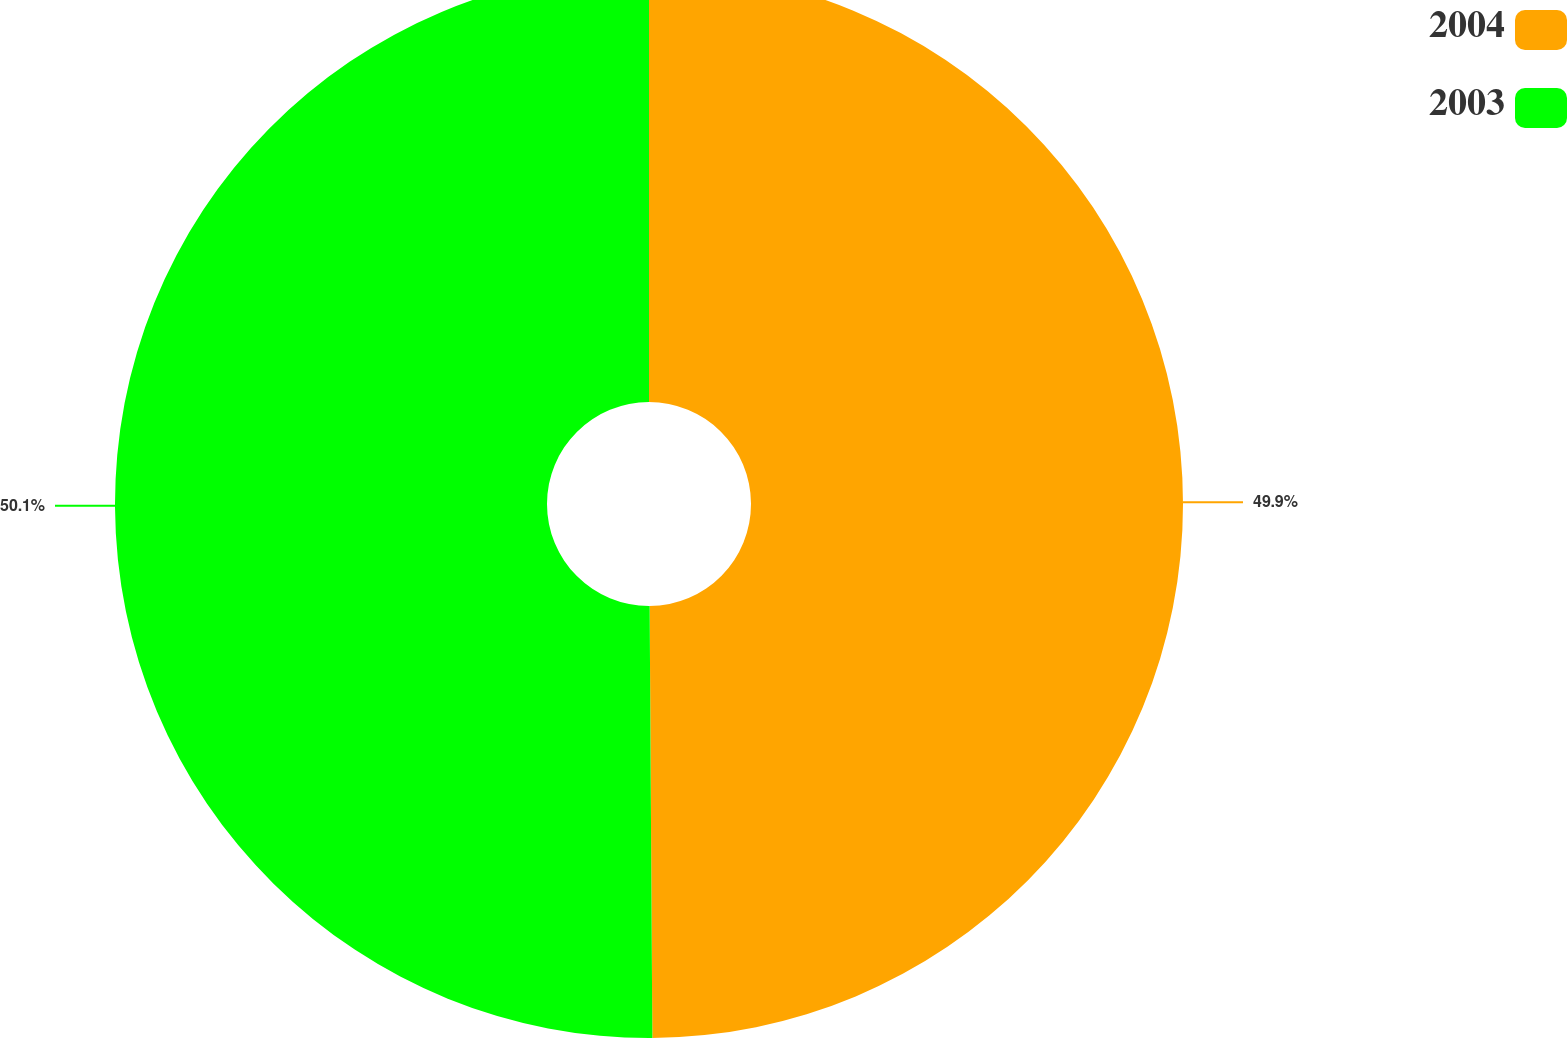Convert chart to OTSL. <chart><loc_0><loc_0><loc_500><loc_500><pie_chart><fcel>2004<fcel>2003<nl><fcel>49.9%<fcel>50.1%<nl></chart> 